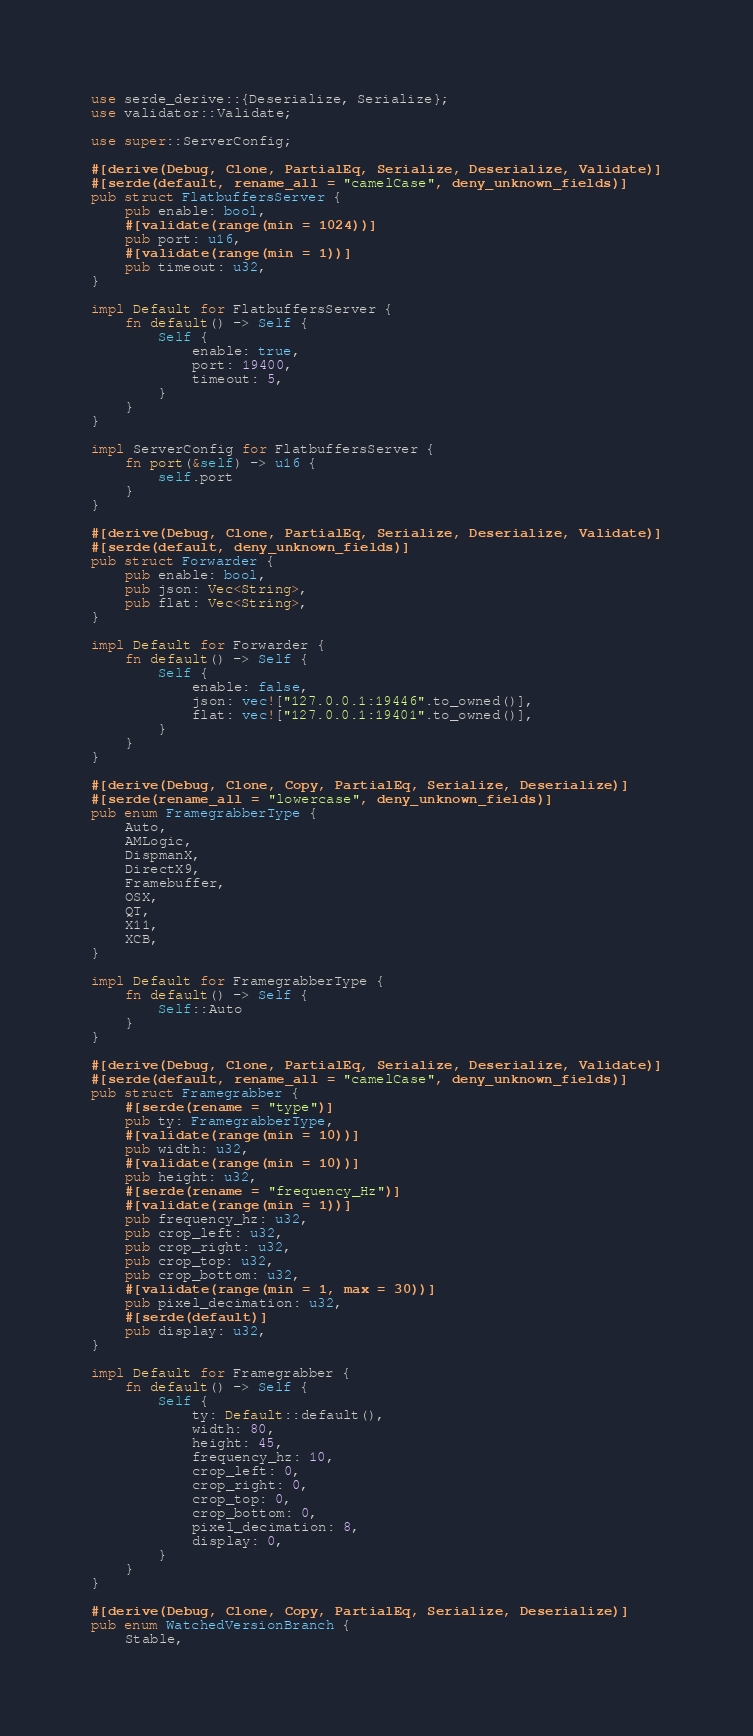<code> <loc_0><loc_0><loc_500><loc_500><_Rust_>use serde_derive::{Deserialize, Serialize};
use validator::Validate;

use super::ServerConfig;

#[derive(Debug, Clone, PartialEq, Serialize, Deserialize, Validate)]
#[serde(default, rename_all = "camelCase", deny_unknown_fields)]
pub struct FlatbuffersServer {
    pub enable: bool,
    #[validate(range(min = 1024))]
    pub port: u16,
    #[validate(range(min = 1))]
    pub timeout: u32,
}

impl Default for FlatbuffersServer {
    fn default() -> Self {
        Self {
            enable: true,
            port: 19400,
            timeout: 5,
        }
    }
}

impl ServerConfig for FlatbuffersServer {
    fn port(&self) -> u16 {
        self.port
    }
}

#[derive(Debug, Clone, PartialEq, Serialize, Deserialize, Validate)]
#[serde(default, deny_unknown_fields)]
pub struct Forwarder {
    pub enable: bool,
    pub json: Vec<String>,
    pub flat: Vec<String>,
}

impl Default for Forwarder {
    fn default() -> Self {
        Self {
            enable: false,
            json: vec!["127.0.0.1:19446".to_owned()],
            flat: vec!["127.0.0.1:19401".to_owned()],
        }
    }
}

#[derive(Debug, Clone, Copy, PartialEq, Serialize, Deserialize)]
#[serde(rename_all = "lowercase", deny_unknown_fields)]
pub enum FramegrabberType {
    Auto,
    AMLogic,
    DispmanX,
    DirectX9,
    Framebuffer,
    OSX,
    QT,
    X11,
    XCB,
}

impl Default for FramegrabberType {
    fn default() -> Self {
        Self::Auto
    }
}

#[derive(Debug, Clone, PartialEq, Serialize, Deserialize, Validate)]
#[serde(default, rename_all = "camelCase", deny_unknown_fields)]
pub struct Framegrabber {
    #[serde(rename = "type")]
    pub ty: FramegrabberType,
    #[validate(range(min = 10))]
    pub width: u32,
    #[validate(range(min = 10))]
    pub height: u32,
    #[serde(rename = "frequency_Hz")]
    #[validate(range(min = 1))]
    pub frequency_hz: u32,
    pub crop_left: u32,
    pub crop_right: u32,
    pub crop_top: u32,
    pub crop_bottom: u32,
    #[validate(range(min = 1, max = 30))]
    pub pixel_decimation: u32,
    #[serde(default)]
    pub display: u32,
}

impl Default for Framegrabber {
    fn default() -> Self {
        Self {
            ty: Default::default(),
            width: 80,
            height: 45,
            frequency_hz: 10,
            crop_left: 0,
            crop_right: 0,
            crop_top: 0,
            crop_bottom: 0,
            pixel_decimation: 8,
            display: 0,
        }
    }
}

#[derive(Debug, Clone, Copy, PartialEq, Serialize, Deserialize)]
pub enum WatchedVersionBranch {
    Stable,</code> 